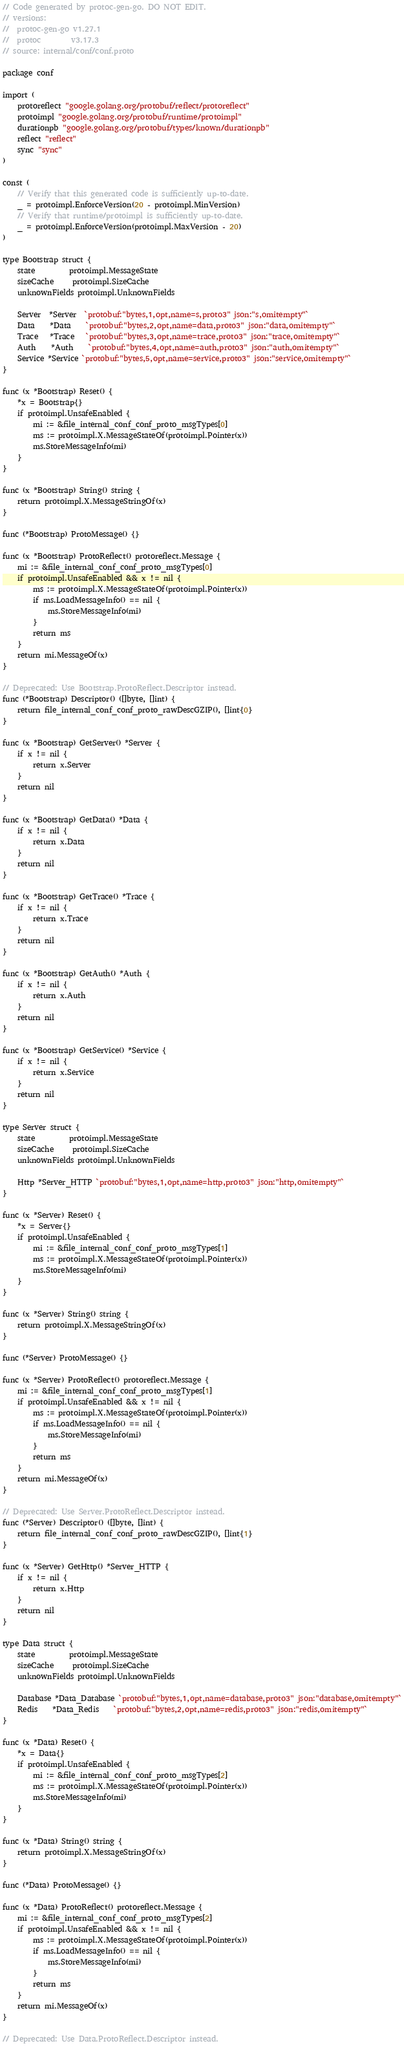Convert code to text. <code><loc_0><loc_0><loc_500><loc_500><_Go_>// Code generated by protoc-gen-go. DO NOT EDIT.
// versions:
// 	protoc-gen-go v1.27.1
// 	protoc        v3.17.3
// source: internal/conf/conf.proto

package conf

import (
	protoreflect "google.golang.org/protobuf/reflect/protoreflect"
	protoimpl "google.golang.org/protobuf/runtime/protoimpl"
	durationpb "google.golang.org/protobuf/types/known/durationpb"
	reflect "reflect"
	sync "sync"
)

const (
	// Verify that this generated code is sufficiently up-to-date.
	_ = protoimpl.EnforceVersion(20 - protoimpl.MinVersion)
	// Verify that runtime/protoimpl is sufficiently up-to-date.
	_ = protoimpl.EnforceVersion(protoimpl.MaxVersion - 20)
)

type Bootstrap struct {
	state         protoimpl.MessageState
	sizeCache     protoimpl.SizeCache
	unknownFields protoimpl.UnknownFields

	Server  *Server  `protobuf:"bytes,1,opt,name=s,proto3" json:"s,omitempty"`
	Data    *Data    `protobuf:"bytes,2,opt,name=data,proto3" json:"data,omitempty"`
	Trace   *Trace   `protobuf:"bytes,3,opt,name=trace,proto3" json:"trace,omitempty"`
	Auth    *Auth    `protobuf:"bytes,4,opt,name=auth,proto3" json:"auth,omitempty"`
	Service *Service `protobuf:"bytes,5,opt,name=service,proto3" json:"service,omitempty"`
}

func (x *Bootstrap) Reset() {
	*x = Bootstrap{}
	if protoimpl.UnsafeEnabled {
		mi := &file_internal_conf_conf_proto_msgTypes[0]
		ms := protoimpl.X.MessageStateOf(protoimpl.Pointer(x))
		ms.StoreMessageInfo(mi)
	}
}

func (x *Bootstrap) String() string {
	return protoimpl.X.MessageStringOf(x)
}

func (*Bootstrap) ProtoMessage() {}

func (x *Bootstrap) ProtoReflect() protoreflect.Message {
	mi := &file_internal_conf_conf_proto_msgTypes[0]
	if protoimpl.UnsafeEnabled && x != nil {
		ms := protoimpl.X.MessageStateOf(protoimpl.Pointer(x))
		if ms.LoadMessageInfo() == nil {
			ms.StoreMessageInfo(mi)
		}
		return ms
	}
	return mi.MessageOf(x)
}

// Deprecated: Use Bootstrap.ProtoReflect.Descriptor instead.
func (*Bootstrap) Descriptor() ([]byte, []int) {
	return file_internal_conf_conf_proto_rawDescGZIP(), []int{0}
}

func (x *Bootstrap) GetServer() *Server {
	if x != nil {
		return x.Server
	}
	return nil
}

func (x *Bootstrap) GetData() *Data {
	if x != nil {
		return x.Data
	}
	return nil
}

func (x *Bootstrap) GetTrace() *Trace {
	if x != nil {
		return x.Trace
	}
	return nil
}

func (x *Bootstrap) GetAuth() *Auth {
	if x != nil {
		return x.Auth
	}
	return nil
}

func (x *Bootstrap) GetService() *Service {
	if x != nil {
		return x.Service
	}
	return nil
}

type Server struct {
	state         protoimpl.MessageState
	sizeCache     protoimpl.SizeCache
	unknownFields protoimpl.UnknownFields

	Http *Server_HTTP `protobuf:"bytes,1,opt,name=http,proto3" json:"http,omitempty"`
}

func (x *Server) Reset() {
	*x = Server{}
	if protoimpl.UnsafeEnabled {
		mi := &file_internal_conf_conf_proto_msgTypes[1]
		ms := protoimpl.X.MessageStateOf(protoimpl.Pointer(x))
		ms.StoreMessageInfo(mi)
	}
}

func (x *Server) String() string {
	return protoimpl.X.MessageStringOf(x)
}

func (*Server) ProtoMessage() {}

func (x *Server) ProtoReflect() protoreflect.Message {
	mi := &file_internal_conf_conf_proto_msgTypes[1]
	if protoimpl.UnsafeEnabled && x != nil {
		ms := protoimpl.X.MessageStateOf(protoimpl.Pointer(x))
		if ms.LoadMessageInfo() == nil {
			ms.StoreMessageInfo(mi)
		}
		return ms
	}
	return mi.MessageOf(x)
}

// Deprecated: Use Server.ProtoReflect.Descriptor instead.
func (*Server) Descriptor() ([]byte, []int) {
	return file_internal_conf_conf_proto_rawDescGZIP(), []int{1}
}

func (x *Server) GetHttp() *Server_HTTP {
	if x != nil {
		return x.Http
	}
	return nil
}

type Data struct {
	state         protoimpl.MessageState
	sizeCache     protoimpl.SizeCache
	unknownFields protoimpl.UnknownFields

	Database *Data_Database `protobuf:"bytes,1,opt,name=database,proto3" json:"database,omitempty"`
	Redis    *Data_Redis    `protobuf:"bytes,2,opt,name=redis,proto3" json:"redis,omitempty"`
}

func (x *Data) Reset() {
	*x = Data{}
	if protoimpl.UnsafeEnabled {
		mi := &file_internal_conf_conf_proto_msgTypes[2]
		ms := protoimpl.X.MessageStateOf(protoimpl.Pointer(x))
		ms.StoreMessageInfo(mi)
	}
}

func (x *Data) String() string {
	return protoimpl.X.MessageStringOf(x)
}

func (*Data) ProtoMessage() {}

func (x *Data) ProtoReflect() protoreflect.Message {
	mi := &file_internal_conf_conf_proto_msgTypes[2]
	if protoimpl.UnsafeEnabled && x != nil {
		ms := protoimpl.X.MessageStateOf(protoimpl.Pointer(x))
		if ms.LoadMessageInfo() == nil {
			ms.StoreMessageInfo(mi)
		}
		return ms
	}
	return mi.MessageOf(x)
}

// Deprecated: Use Data.ProtoReflect.Descriptor instead.</code> 